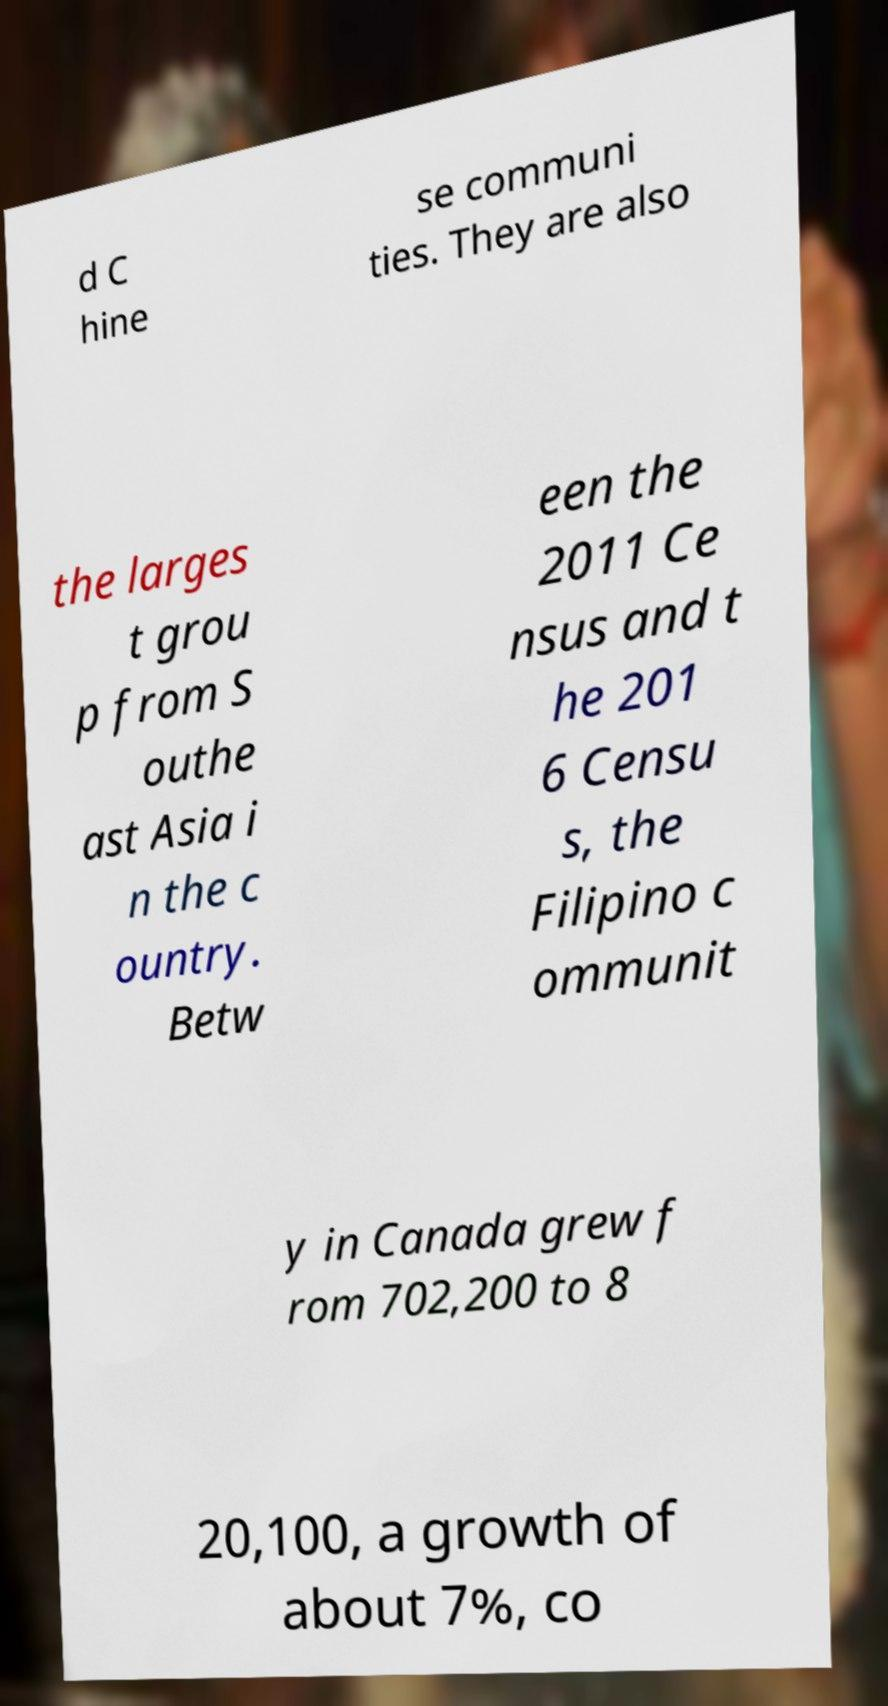For documentation purposes, I need the text within this image transcribed. Could you provide that? d C hine se communi ties. They are also the larges t grou p from S outhe ast Asia i n the c ountry. Betw een the 2011 Ce nsus and t he 201 6 Censu s, the Filipino c ommunit y in Canada grew f rom 702,200 to 8 20,100, a growth of about 7%, co 